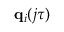<formula> <loc_0><loc_0><loc_500><loc_500>q _ { i } ( j \tau )</formula> 